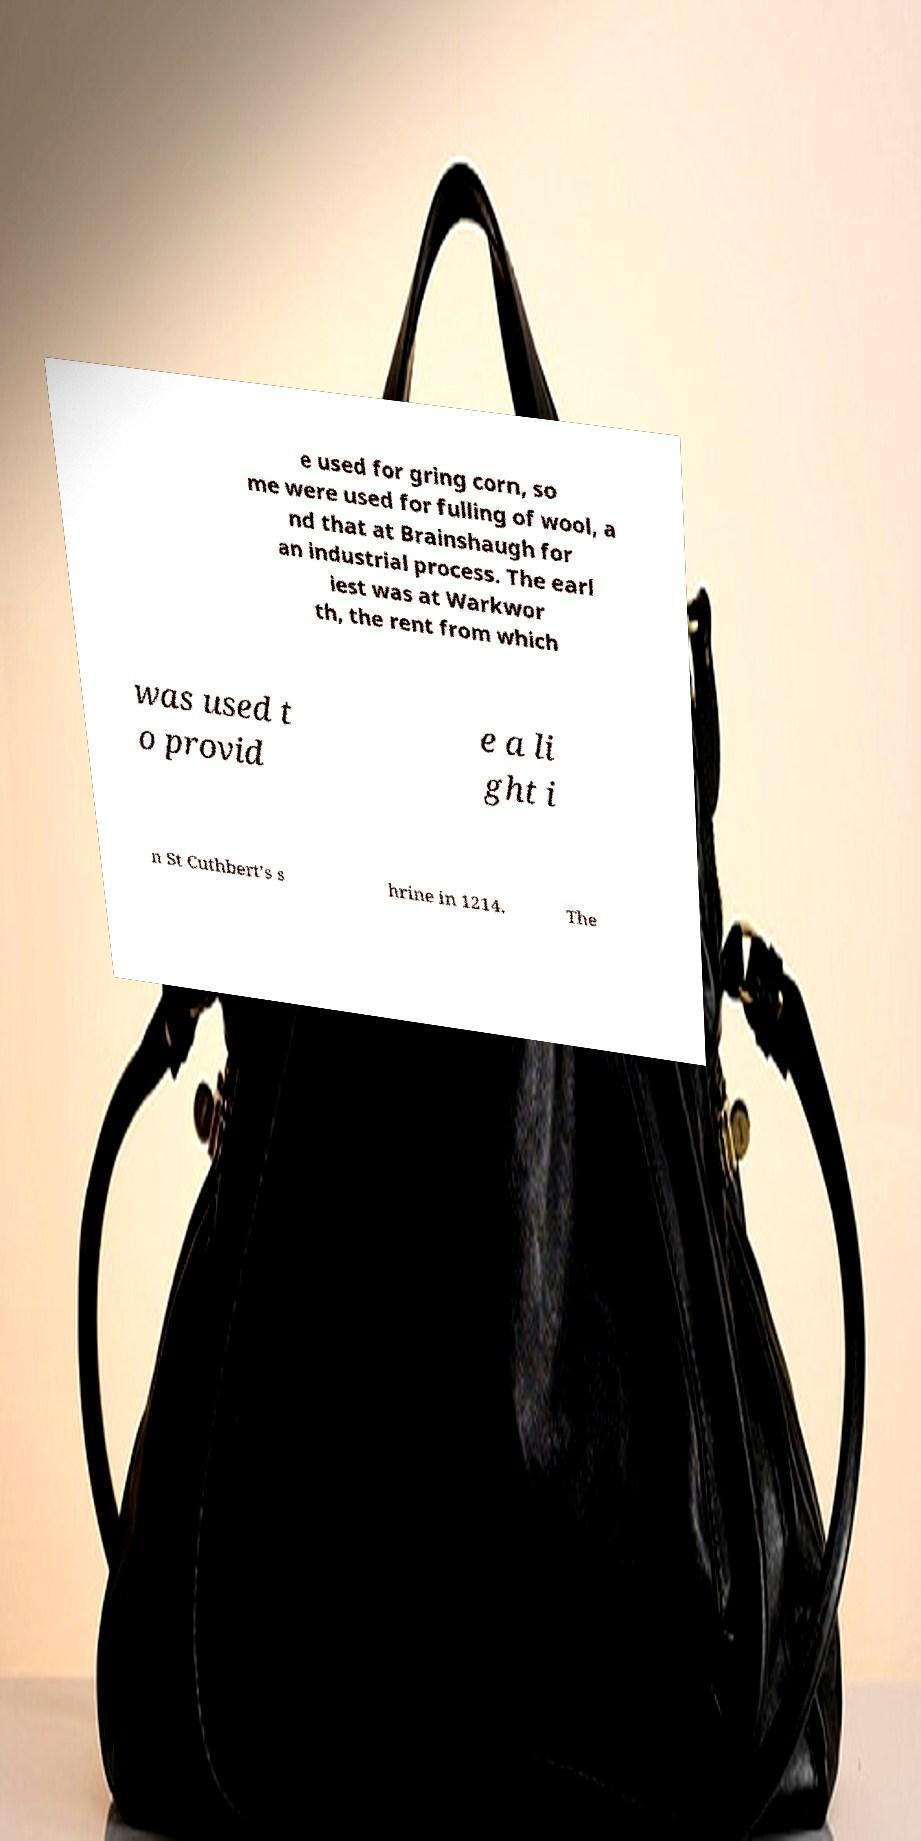Please read and relay the text visible in this image. What does it say? e used for gring corn, so me were used for fulling of wool, a nd that at Brainshaugh for an industrial process. The earl iest was at Warkwor th, the rent from which was used t o provid e a li ght i n St Cuthbert’s s hrine in 1214. The 